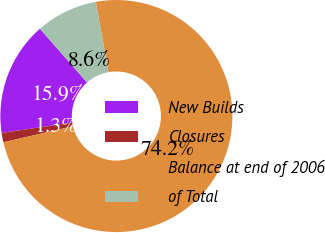Convert chart to OTSL. <chart><loc_0><loc_0><loc_500><loc_500><pie_chart><fcel>New Builds<fcel>Closures<fcel>Balance at end of 2006<fcel>of Total<nl><fcel>15.89%<fcel>1.31%<fcel>74.21%<fcel>8.6%<nl></chart> 